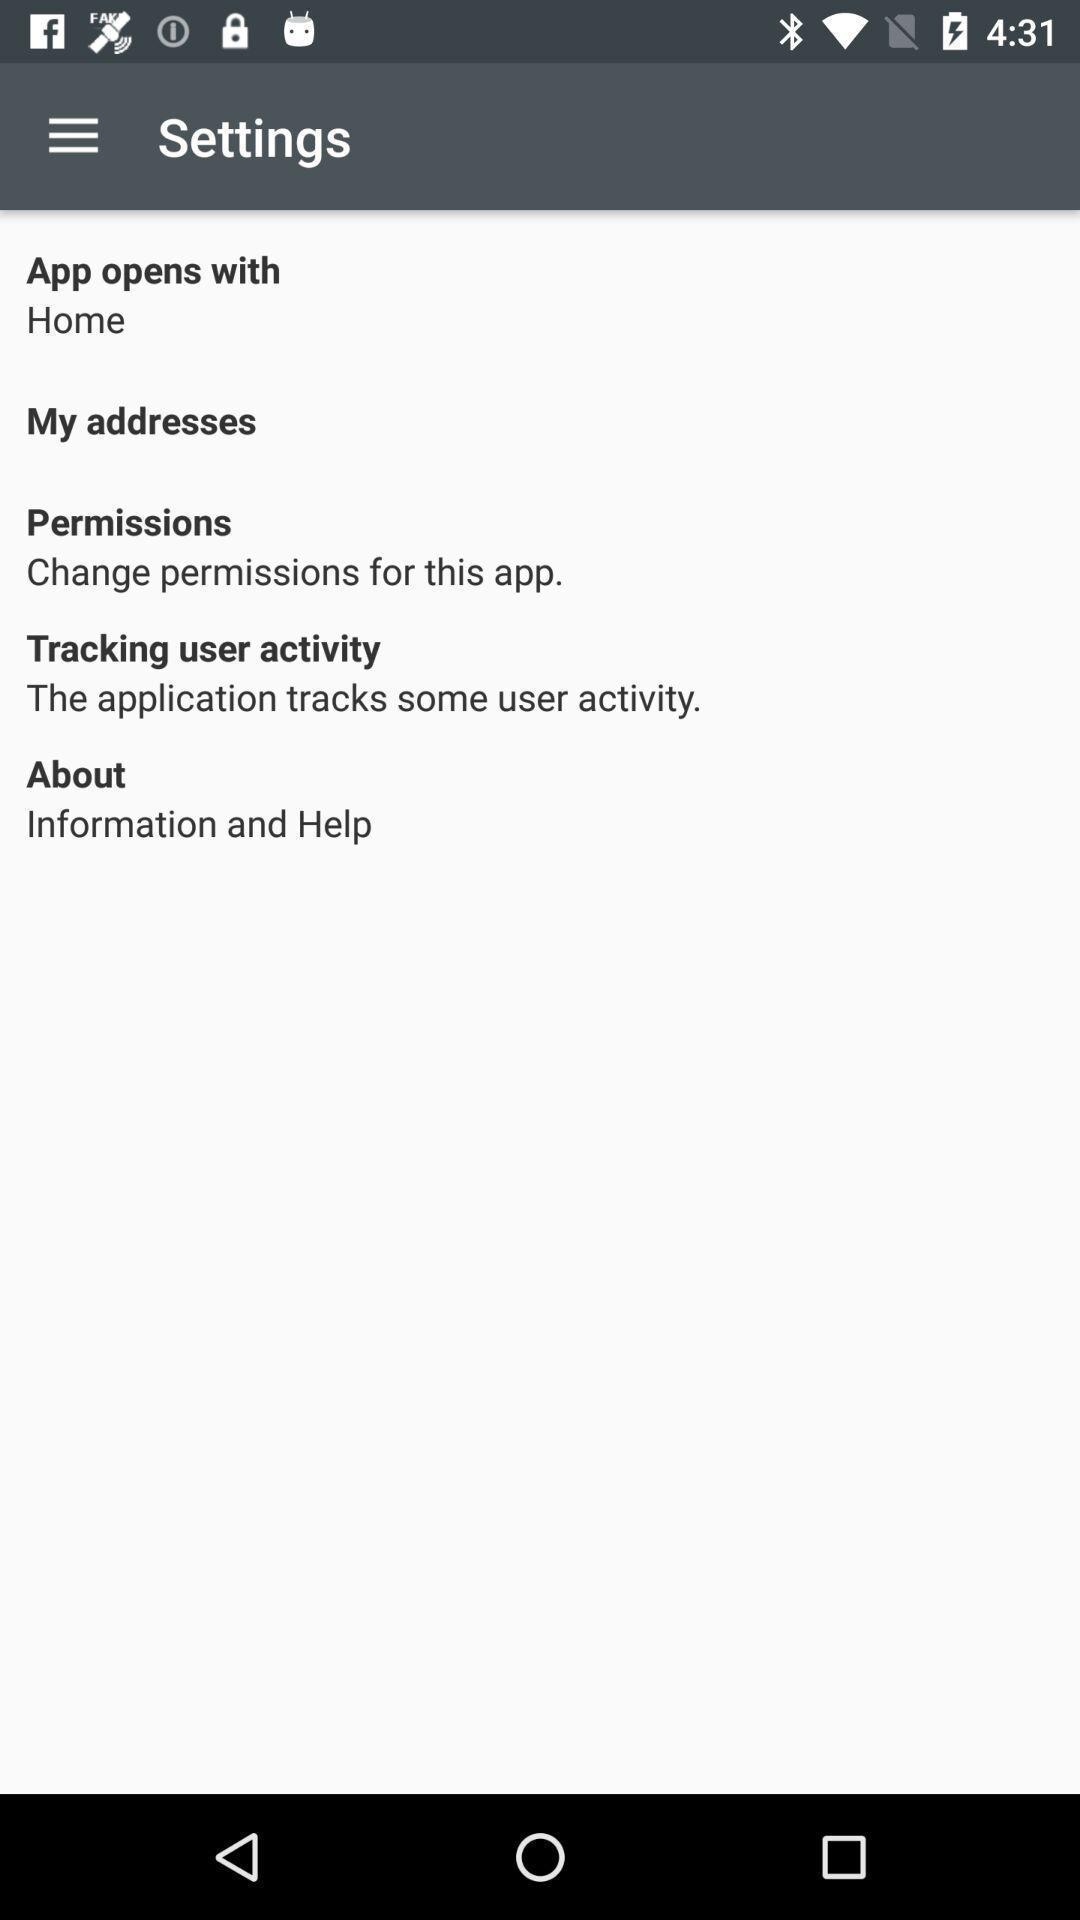Describe the visual elements of this screenshot. Screen displaying multiple setting options. 